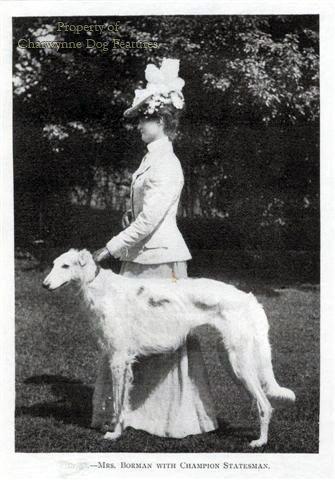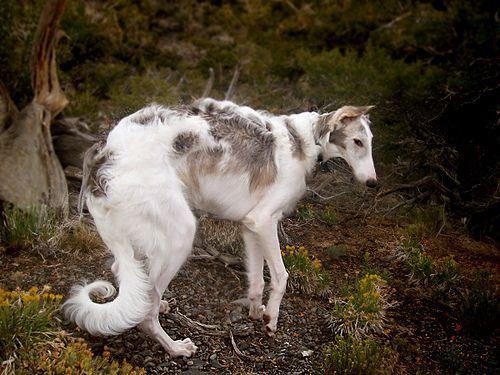The first image is the image on the left, the second image is the image on the right. For the images displayed, is the sentence "There are exactly two dogs in total." factually correct? Answer yes or no. Yes. The first image is the image on the left, the second image is the image on the right. Examine the images to the left and right. Is the description "An image includes at least one person standing behind a standing afghan hound outdoors." accurate? Answer yes or no. Yes. 